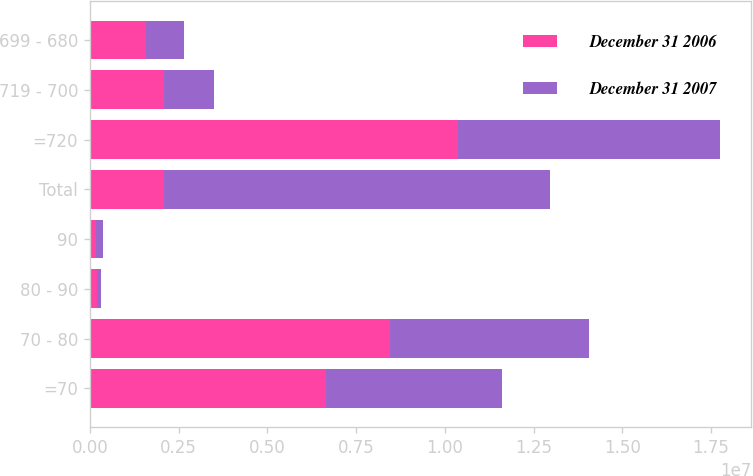Convert chart. <chart><loc_0><loc_0><loc_500><loc_500><stacked_bar_chart><ecel><fcel>=70<fcel>70 - 80<fcel>80 - 90<fcel>90<fcel>Total<fcel>=720<fcel>719 - 700<fcel>699 - 680<nl><fcel>December 31 2006<fcel>6.66621e+06<fcel>8.45098e+06<fcel>202133<fcel>187207<fcel>2.08901e+06<fcel>1.03738e+07<fcel>2.08901e+06<fcel>1.58561e+06<nl><fcel>December 31 2007<fcel>4.95795e+06<fcel>5.60392e+06<fcel>127519<fcel>180826<fcel>1.08702e+07<fcel>7.37065e+06<fcel>1.41146e+06<fcel>1.07324e+06<nl></chart> 